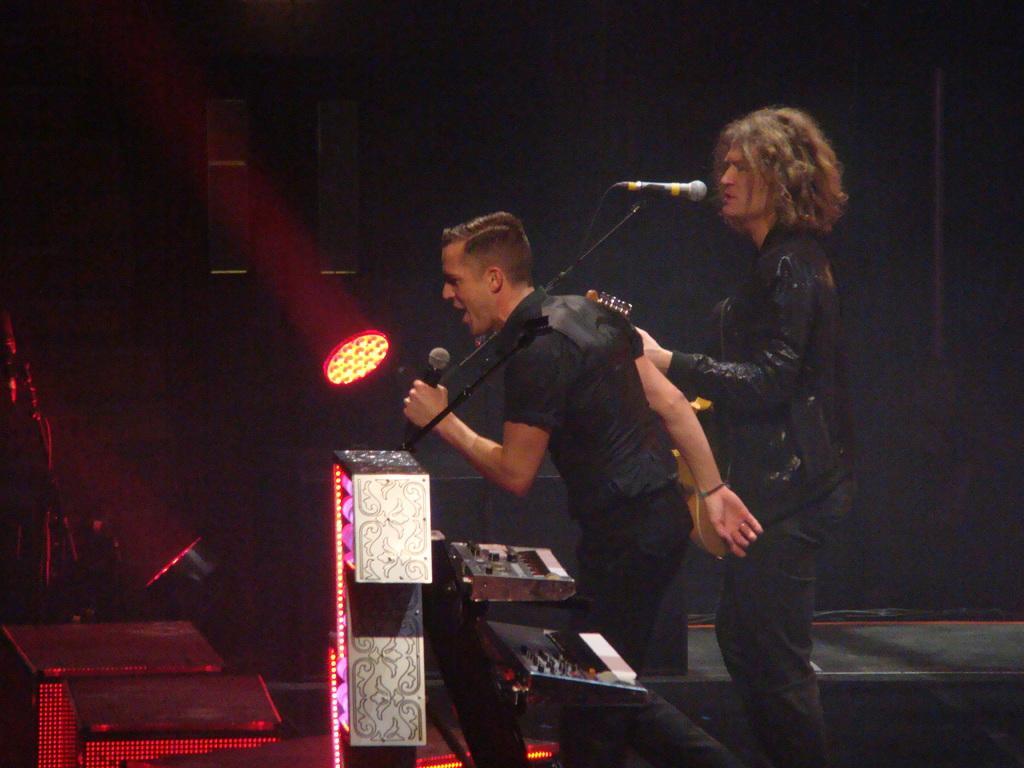In one or two sentences, can you explain what this image depicts? In this picture, we see two men are standing. They are singing the song on the microphone. The man on the left side is holding a microphone in her hands. In front of them, we see table and music recorders. They might be standing on the stage. In the background, it is black in color. This picture might be clicked in the musical concert. 